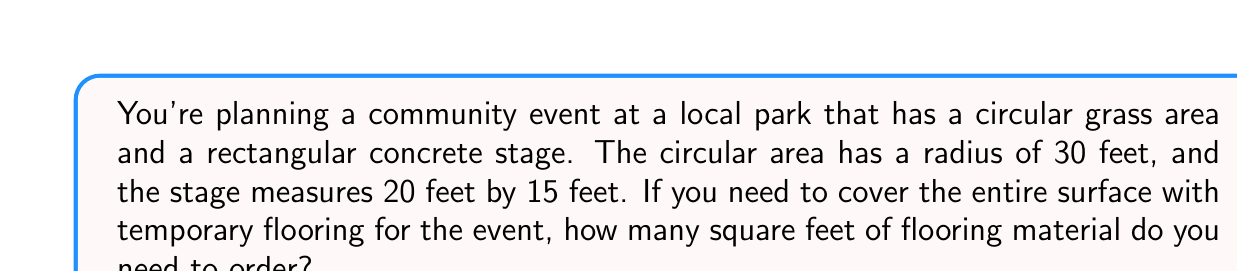Can you answer this question? Let's break this down step-by-step:

1) First, we need to calculate the area of the circular grass area:
   The formula for the area of a circle is $A = \pi r^2$
   $$A_{circle} = \pi (30 \text{ ft})^2 = 900\pi \text{ sq ft}$$

2) Next, we calculate the area of the rectangular stage:
   The formula for the area of a rectangle is $A = l \times w$
   $$A_{rectangle} = 20 \text{ ft} \times 15 \text{ ft} = 300 \text{ sq ft}$$

3) Now, we add these two areas together:
   $$A_{total} = A_{circle} + A_{rectangle} = 900\pi \text{ sq ft} + 300 \text{ sq ft}$$

4) Simplify:
   $$A_{total} = 900\pi + 300 \text{ sq ft}$$

5) Calculate the final value (rounded to the nearest square foot):
   $$A_{total} \approx 3,127 \text{ sq ft}$$

Therefore, you need to order approximately 3,127 square feet of flooring material for your community event.
Answer: 3,127 sq ft 